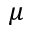<formula> <loc_0><loc_0><loc_500><loc_500>\mu</formula> 